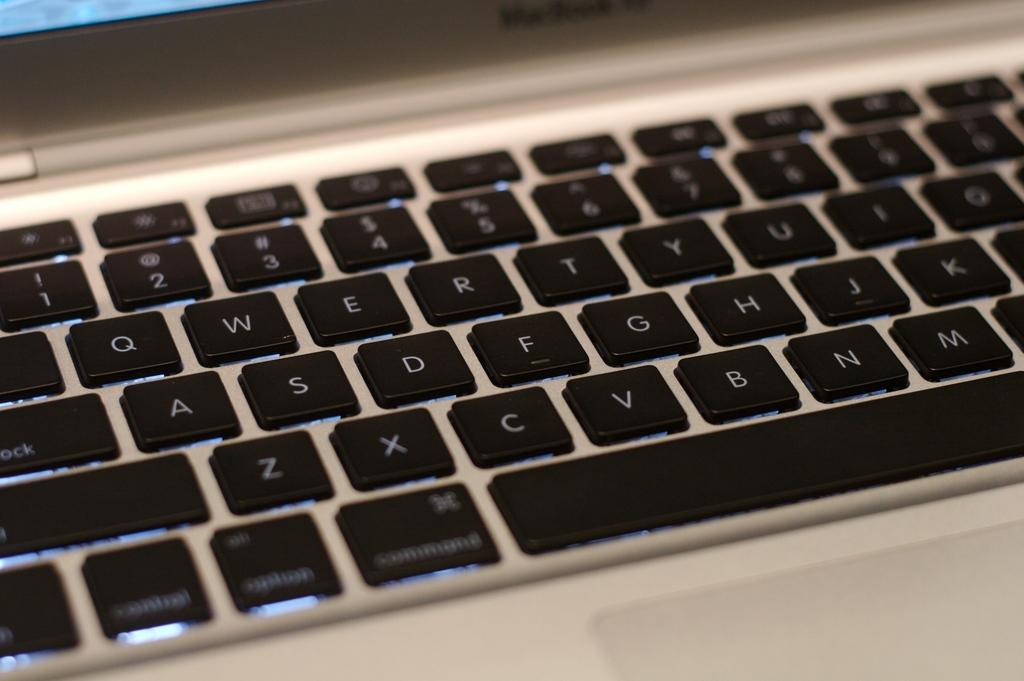What electronic device is visible in the image? There is a laptop in the image. What is placed in front of the laptop? There is a keypad in front of the laptop. What can be said about the color of the keys on the keypad? The keys on the keypad are black in color. What type of food is being prepared on the laptop in the image? There is no food preparation or cooking activity taking place on the laptop in the image. 